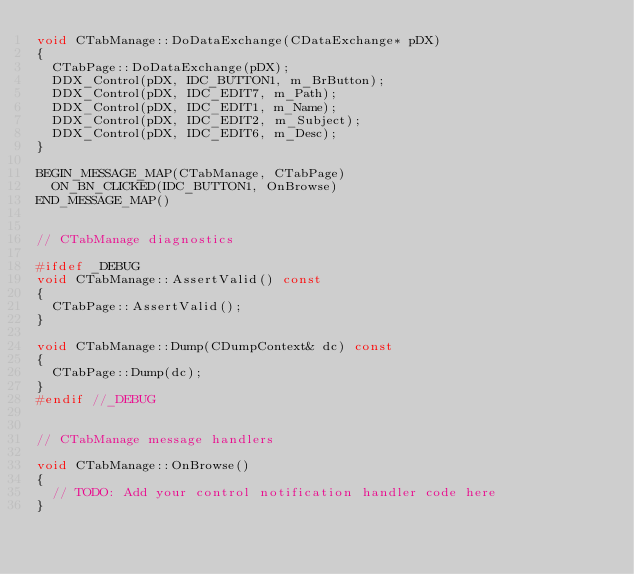<code> <loc_0><loc_0><loc_500><loc_500><_C++_>void CTabManage::DoDataExchange(CDataExchange* pDX)
{
	CTabPage::DoDataExchange(pDX);
	DDX_Control(pDX, IDC_BUTTON1, m_BrButton);
	DDX_Control(pDX, IDC_EDIT7, m_Path);
	DDX_Control(pDX, IDC_EDIT1, m_Name);
	DDX_Control(pDX, IDC_EDIT2, m_Subject);
	DDX_Control(pDX, IDC_EDIT6, m_Desc);
}

BEGIN_MESSAGE_MAP(CTabManage, CTabPage)
	ON_BN_CLICKED(IDC_BUTTON1, OnBrowse)
END_MESSAGE_MAP()


// CTabManage diagnostics

#ifdef _DEBUG
void CTabManage::AssertValid() const
{
	CTabPage::AssertValid();
}

void CTabManage::Dump(CDumpContext& dc) const
{
	CTabPage::Dump(dc);
}
#endif //_DEBUG


// CTabManage message handlers

void CTabManage::OnBrowse()
{
	// TODO: Add your control notification handler code here
}
</code> 